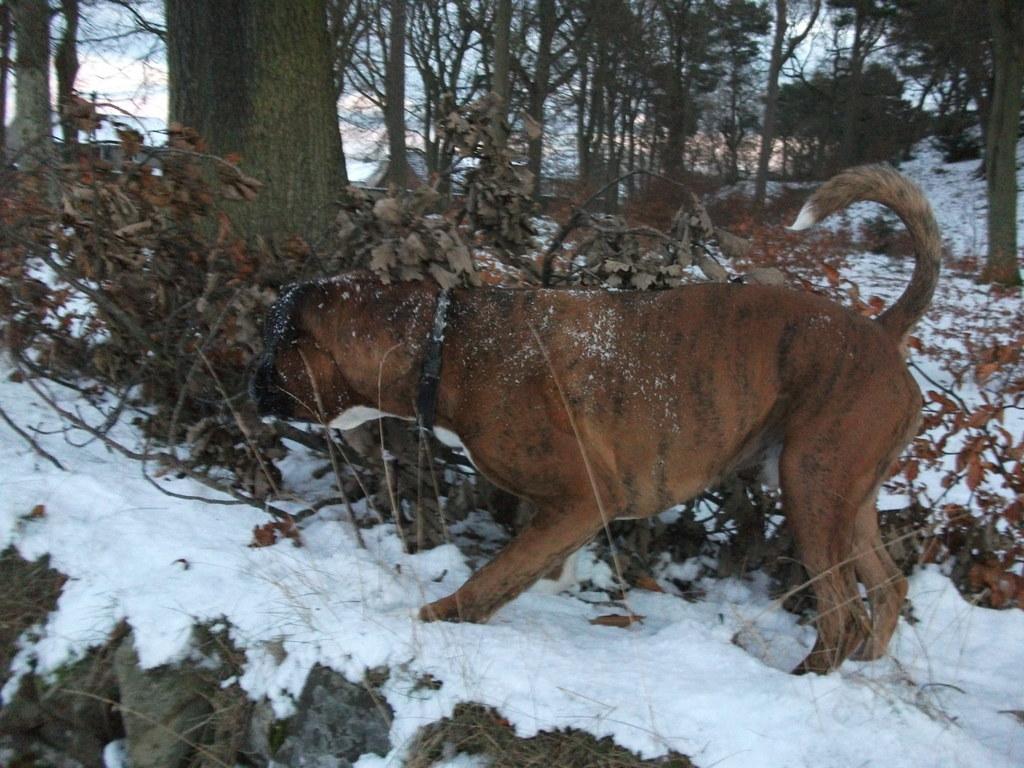Describe this image in one or two sentences. In this image there is a dog standing on the snow in the center. In the background there are dry leaves and there are trees. On the ground there is snow. 